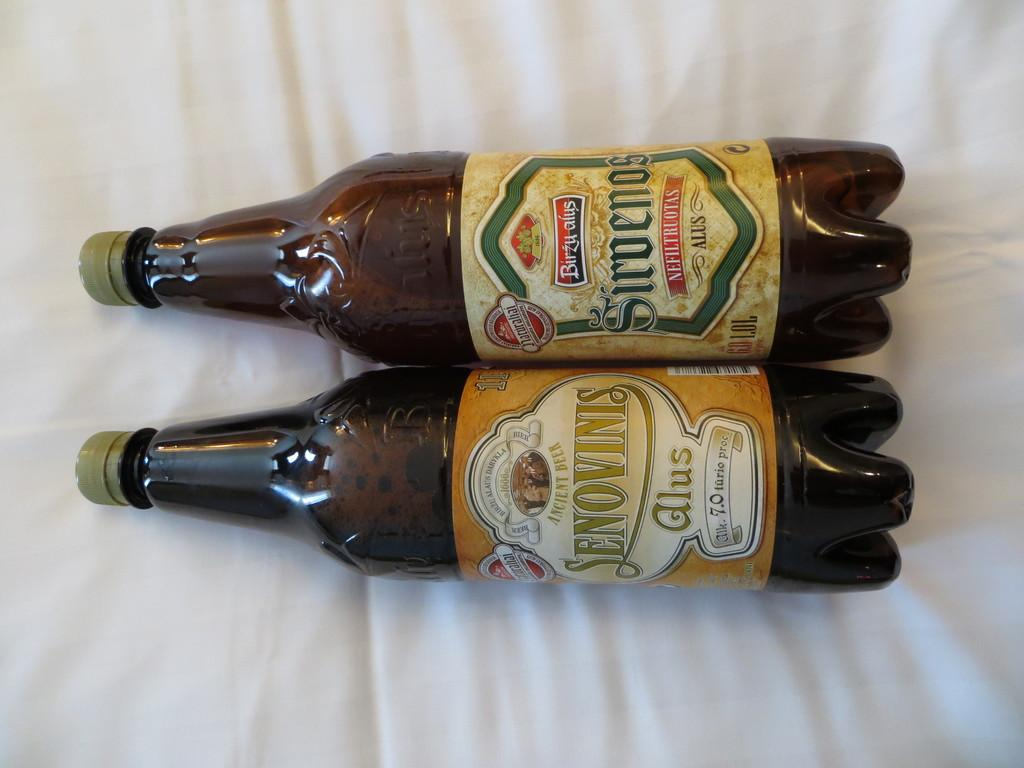How many bottles are visible in the image? There are two bottles in the image. What is the bottles resting on in the image? The bottles are laid on a white cloth. How many people are in the crowd surrounding the bottles in the image? There is no crowd present in the image; it only features two bottles laid on a white cloth. 